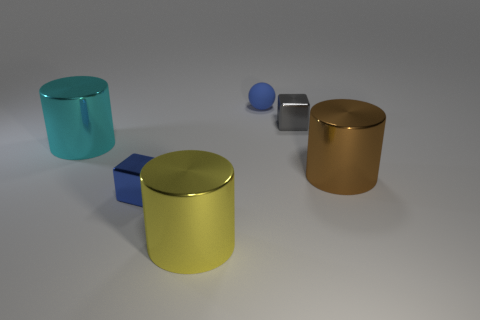Add 1 big cyan cylinders. How many objects exist? 7 Subtract all spheres. How many objects are left? 5 Add 5 blue spheres. How many blue spheres are left? 6 Add 5 yellow cylinders. How many yellow cylinders exist? 6 Subtract 1 brown cylinders. How many objects are left? 5 Subtract all tiny cyan shiny cylinders. Subtract all tiny blue shiny cubes. How many objects are left? 5 